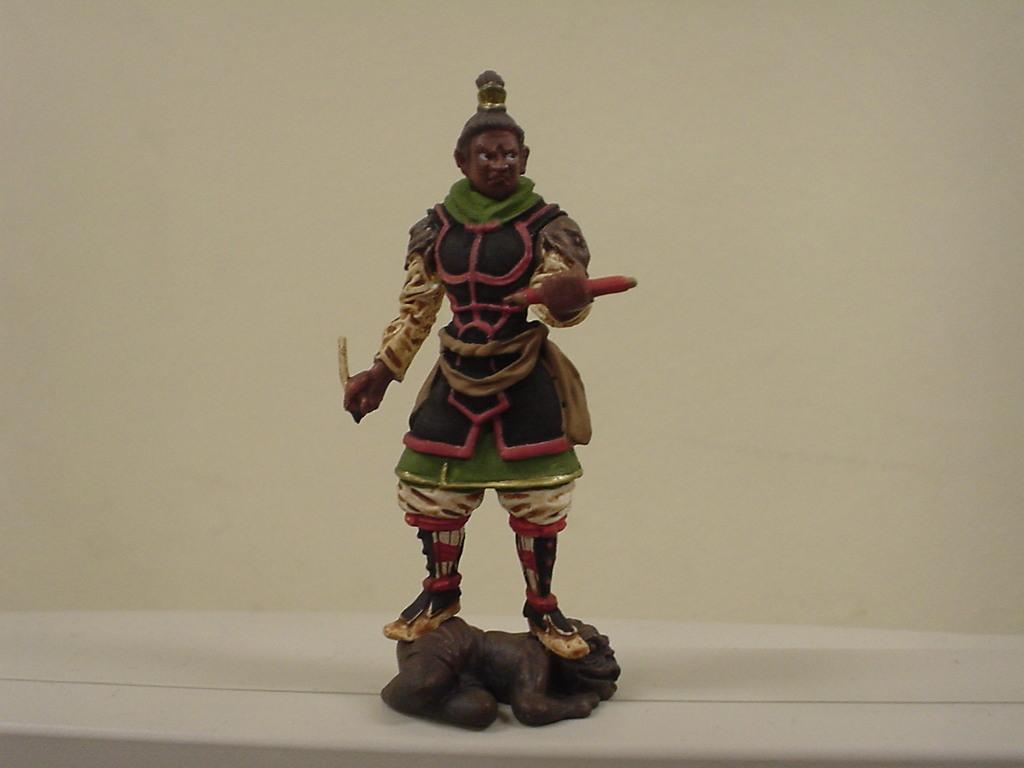Can you describe this image briefly? In this image we can see a statue and in the background, we can see the wall. 